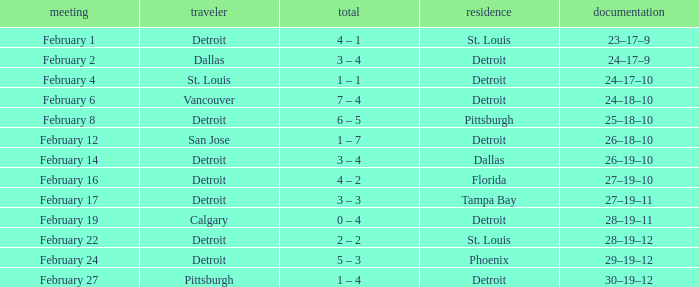What was their record on February 24? 29–19–12. 